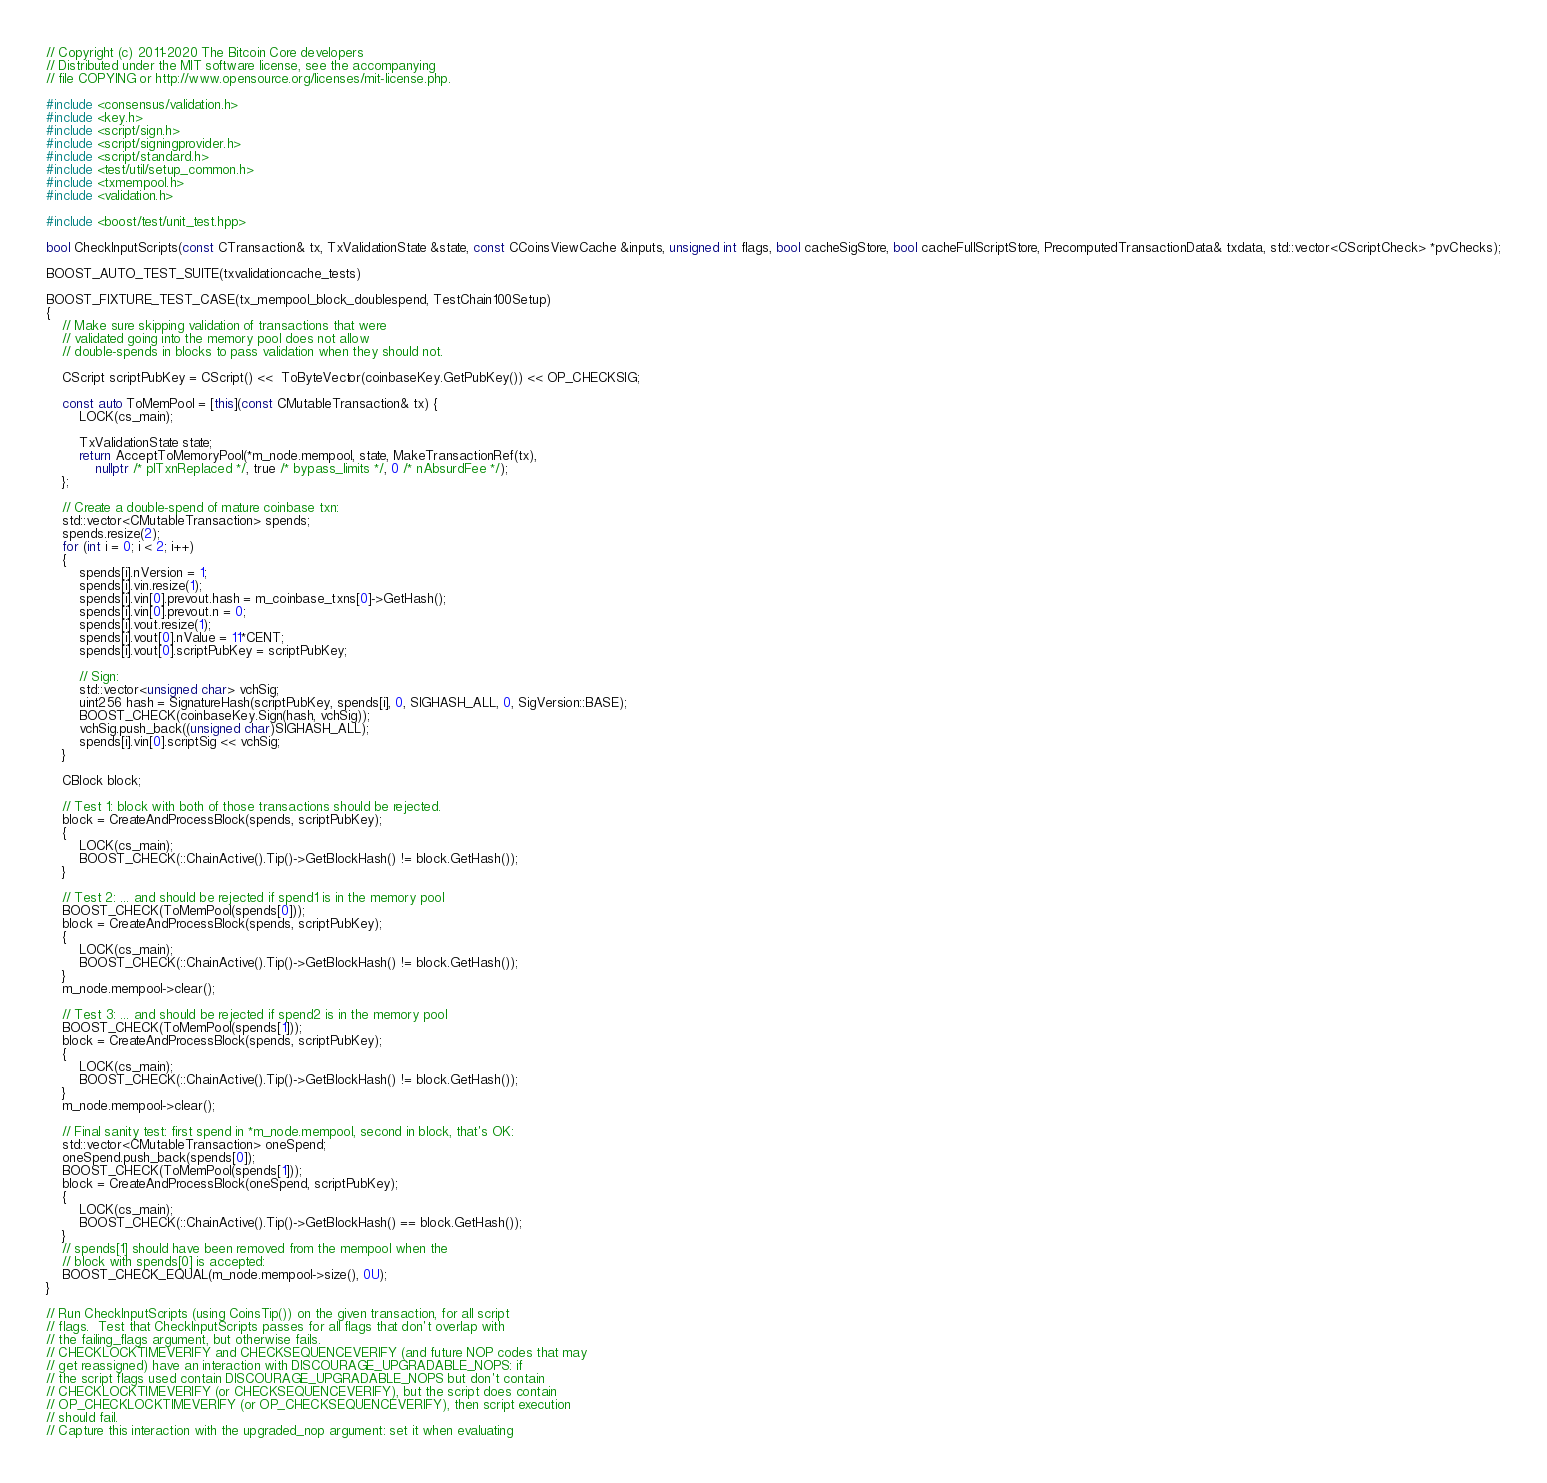Convert code to text. <code><loc_0><loc_0><loc_500><loc_500><_C++_>// Copyright (c) 2011-2020 The Bitcoin Core developers
// Distributed under the MIT software license, see the accompanying
// file COPYING or http://www.opensource.org/licenses/mit-license.php.

#include <consensus/validation.h>
#include <key.h>
#include <script/sign.h>
#include <script/signingprovider.h>
#include <script/standard.h>
#include <test/util/setup_common.h>
#include <txmempool.h>
#include <validation.h>

#include <boost/test/unit_test.hpp>

bool CheckInputScripts(const CTransaction& tx, TxValidationState &state, const CCoinsViewCache &inputs, unsigned int flags, bool cacheSigStore, bool cacheFullScriptStore, PrecomputedTransactionData& txdata, std::vector<CScriptCheck> *pvChecks);

BOOST_AUTO_TEST_SUITE(txvalidationcache_tests)

BOOST_FIXTURE_TEST_CASE(tx_mempool_block_doublespend, TestChain100Setup)
{
    // Make sure skipping validation of transactions that were
    // validated going into the memory pool does not allow
    // double-spends in blocks to pass validation when they should not.

    CScript scriptPubKey = CScript() <<  ToByteVector(coinbaseKey.GetPubKey()) << OP_CHECKSIG;

    const auto ToMemPool = [this](const CMutableTransaction& tx) {
        LOCK(cs_main);

        TxValidationState state;
        return AcceptToMemoryPool(*m_node.mempool, state, MakeTransactionRef(tx),
            nullptr /* plTxnReplaced */, true /* bypass_limits */, 0 /* nAbsurdFee */);
    };

    // Create a double-spend of mature coinbase txn:
    std::vector<CMutableTransaction> spends;
    spends.resize(2);
    for (int i = 0; i < 2; i++)
    {
        spends[i].nVersion = 1;
        spends[i].vin.resize(1);
        spends[i].vin[0].prevout.hash = m_coinbase_txns[0]->GetHash();
        spends[i].vin[0].prevout.n = 0;
        spends[i].vout.resize(1);
        spends[i].vout[0].nValue = 11*CENT;
        spends[i].vout[0].scriptPubKey = scriptPubKey;

        // Sign:
        std::vector<unsigned char> vchSig;
        uint256 hash = SignatureHash(scriptPubKey, spends[i], 0, SIGHASH_ALL, 0, SigVersion::BASE);
        BOOST_CHECK(coinbaseKey.Sign(hash, vchSig));
        vchSig.push_back((unsigned char)SIGHASH_ALL);
        spends[i].vin[0].scriptSig << vchSig;
    }

    CBlock block;

    // Test 1: block with both of those transactions should be rejected.
    block = CreateAndProcessBlock(spends, scriptPubKey);
    {
        LOCK(cs_main);
        BOOST_CHECK(::ChainActive().Tip()->GetBlockHash() != block.GetHash());
    }

    // Test 2: ... and should be rejected if spend1 is in the memory pool
    BOOST_CHECK(ToMemPool(spends[0]));
    block = CreateAndProcessBlock(spends, scriptPubKey);
    {
        LOCK(cs_main);
        BOOST_CHECK(::ChainActive().Tip()->GetBlockHash() != block.GetHash());
    }
    m_node.mempool->clear();

    // Test 3: ... and should be rejected if spend2 is in the memory pool
    BOOST_CHECK(ToMemPool(spends[1]));
    block = CreateAndProcessBlock(spends, scriptPubKey);
    {
        LOCK(cs_main);
        BOOST_CHECK(::ChainActive().Tip()->GetBlockHash() != block.GetHash());
    }
    m_node.mempool->clear();

    // Final sanity test: first spend in *m_node.mempool, second in block, that's OK:
    std::vector<CMutableTransaction> oneSpend;
    oneSpend.push_back(spends[0]);
    BOOST_CHECK(ToMemPool(spends[1]));
    block = CreateAndProcessBlock(oneSpend, scriptPubKey);
    {
        LOCK(cs_main);
        BOOST_CHECK(::ChainActive().Tip()->GetBlockHash() == block.GetHash());
    }
    // spends[1] should have been removed from the mempool when the
    // block with spends[0] is accepted:
    BOOST_CHECK_EQUAL(m_node.mempool->size(), 0U);
}

// Run CheckInputScripts (using CoinsTip()) on the given transaction, for all script
// flags.  Test that CheckInputScripts passes for all flags that don't overlap with
// the failing_flags argument, but otherwise fails.
// CHECKLOCKTIMEVERIFY and CHECKSEQUENCEVERIFY (and future NOP codes that may
// get reassigned) have an interaction with DISCOURAGE_UPGRADABLE_NOPS: if
// the script flags used contain DISCOURAGE_UPGRADABLE_NOPS but don't contain
// CHECKLOCKTIMEVERIFY (or CHECKSEQUENCEVERIFY), but the script does contain
// OP_CHECKLOCKTIMEVERIFY (or OP_CHECKSEQUENCEVERIFY), then script execution
// should fail.
// Capture this interaction with the upgraded_nop argument: set it when evaluating</code> 